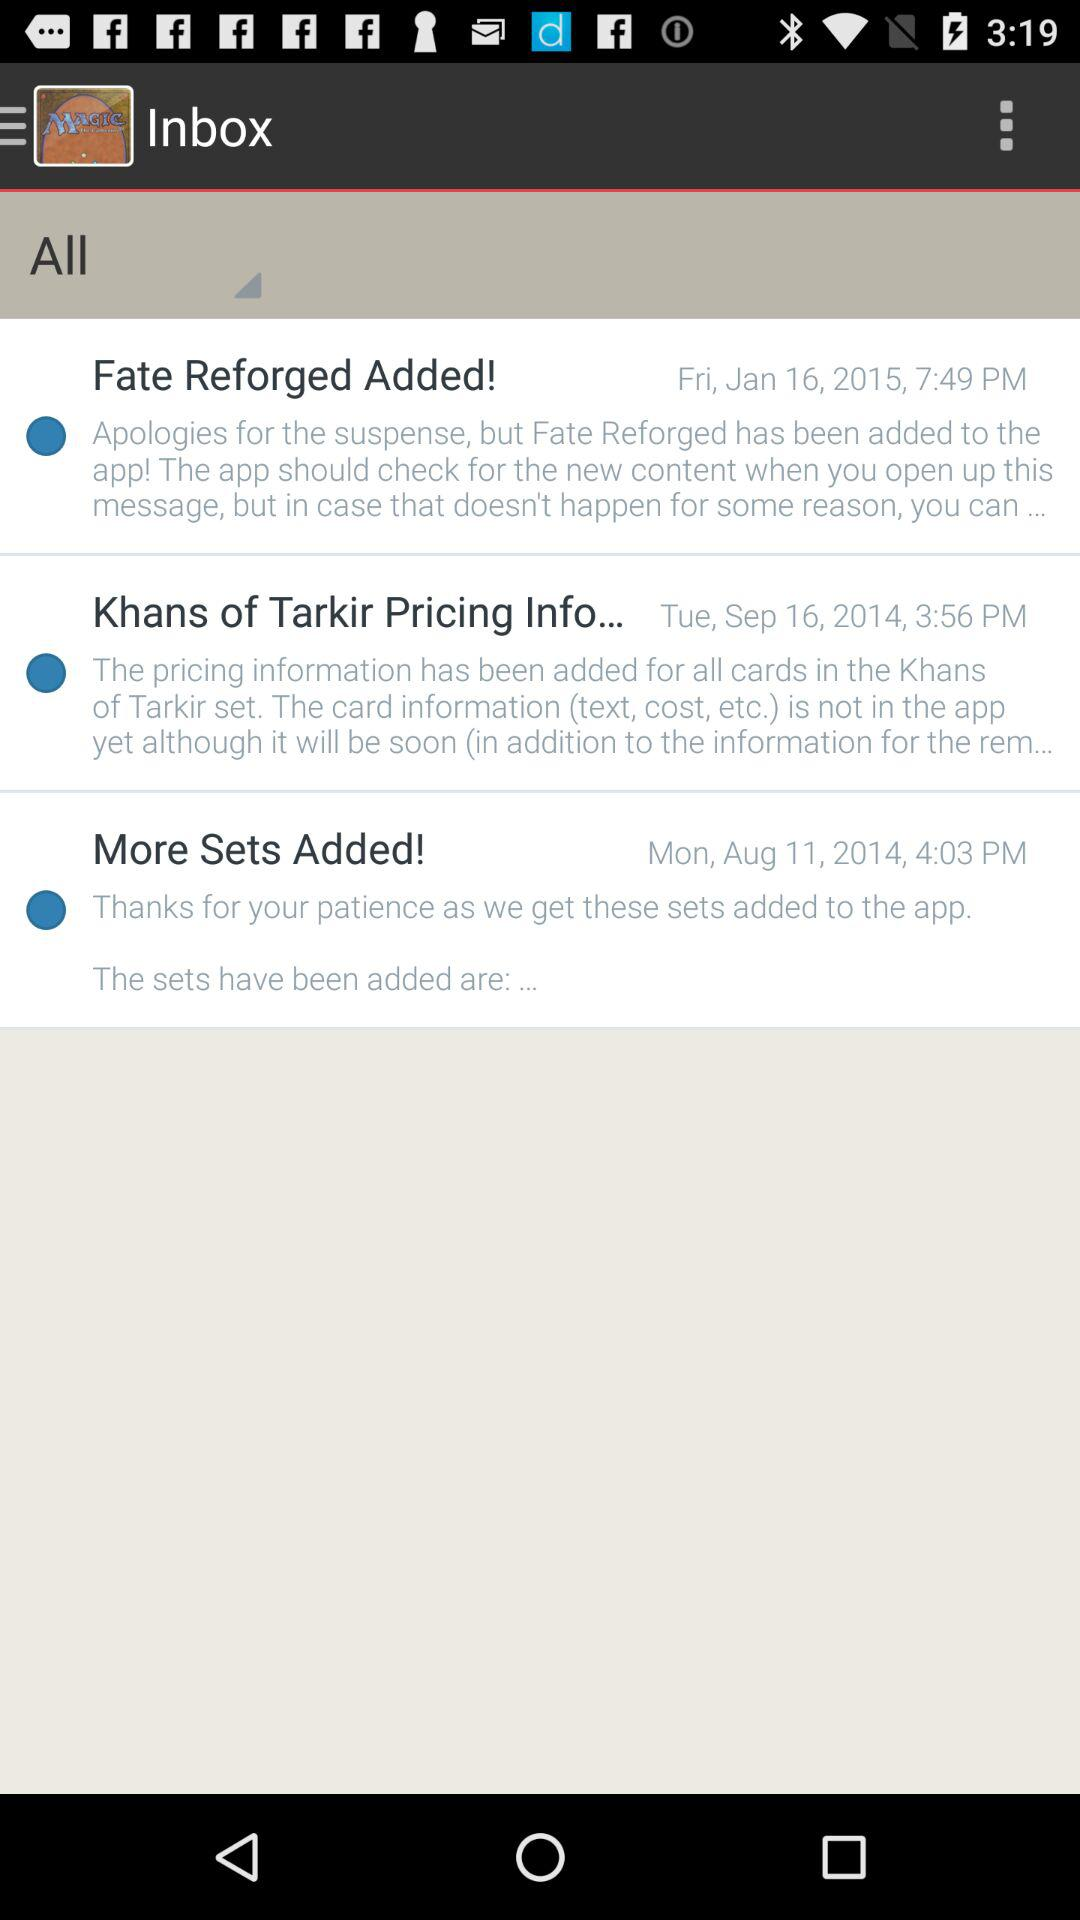How many messages are in the inbox?
Answer the question using a single word or phrase. 3 